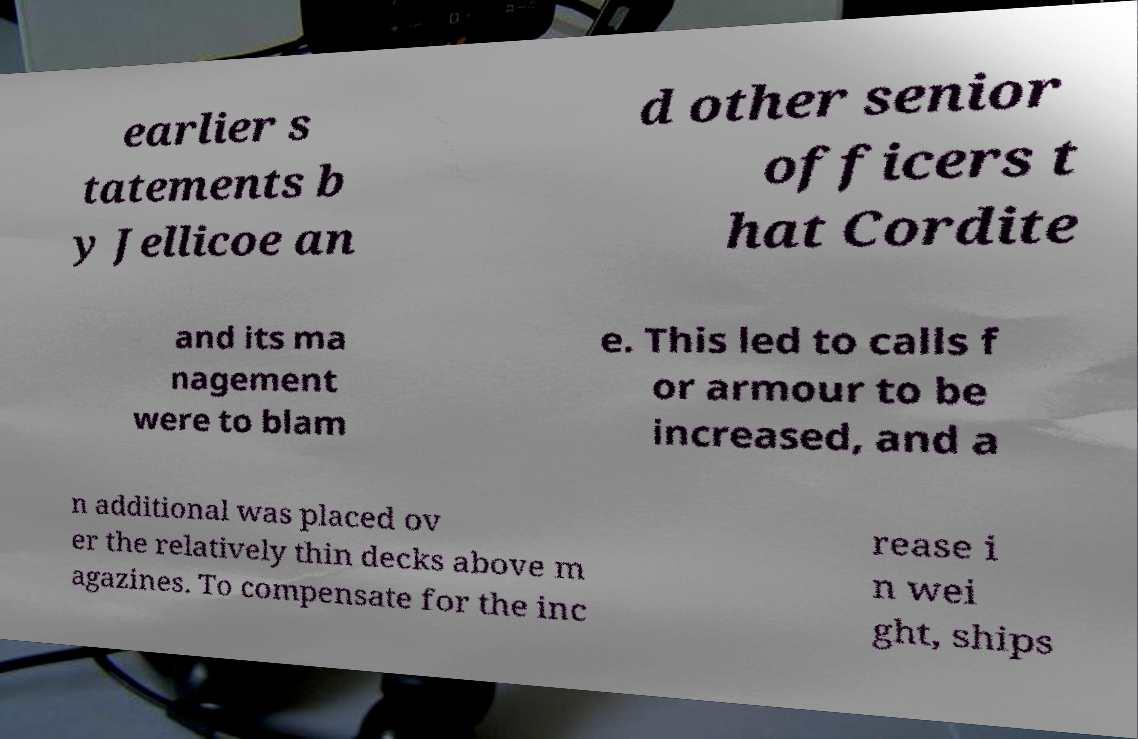Could you assist in decoding the text presented in this image and type it out clearly? earlier s tatements b y Jellicoe an d other senior officers t hat Cordite and its ma nagement were to blam e. This led to calls f or armour to be increased, and a n additional was placed ov er the relatively thin decks above m agazines. To compensate for the inc rease i n wei ght, ships 